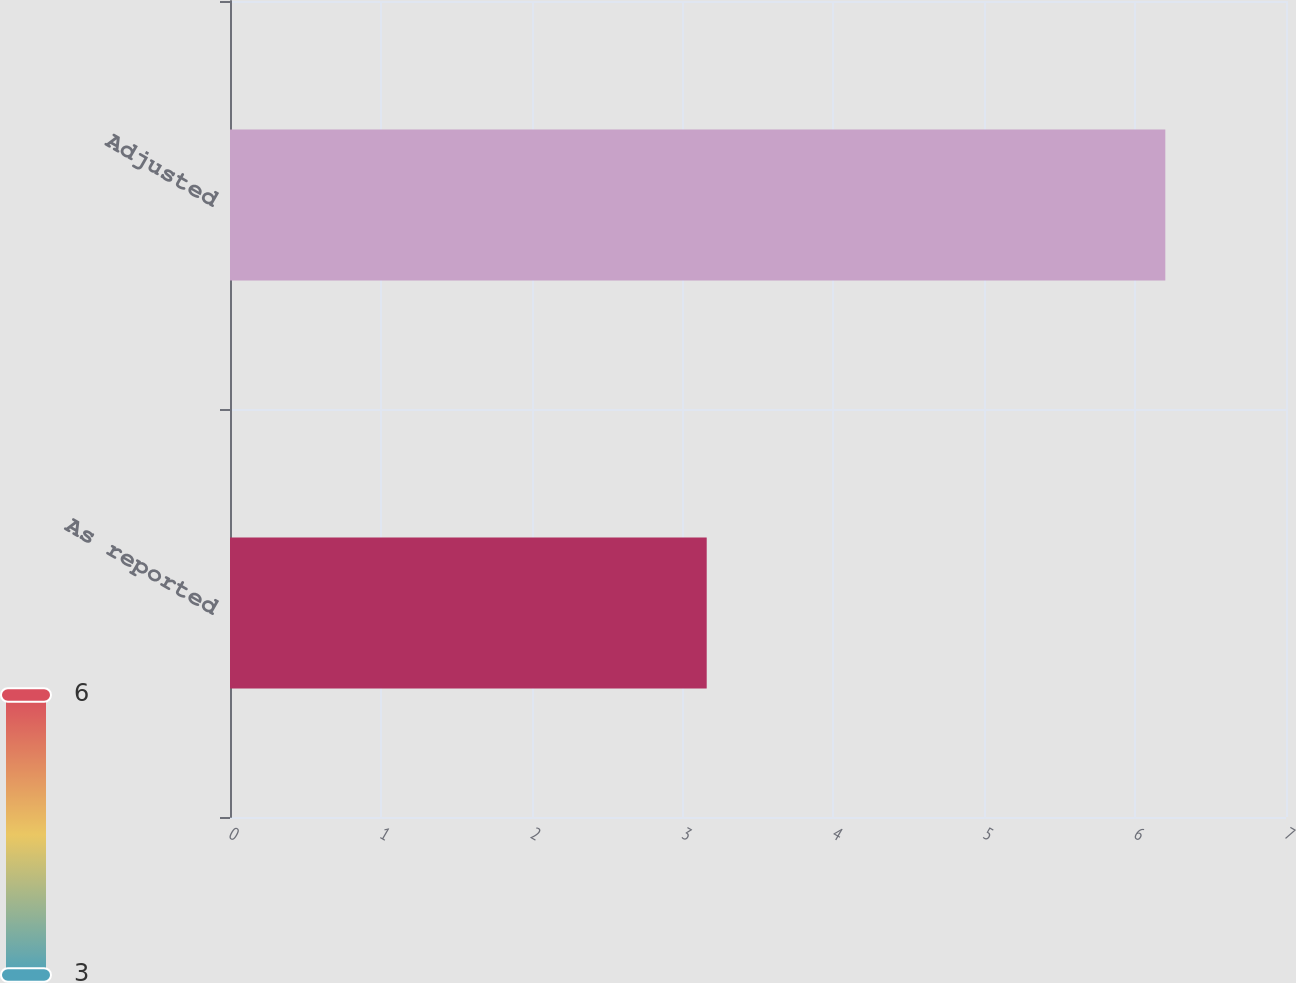Convert chart to OTSL. <chart><loc_0><loc_0><loc_500><loc_500><bar_chart><fcel>As reported<fcel>Adjusted<nl><fcel>3.16<fcel>6.2<nl></chart> 